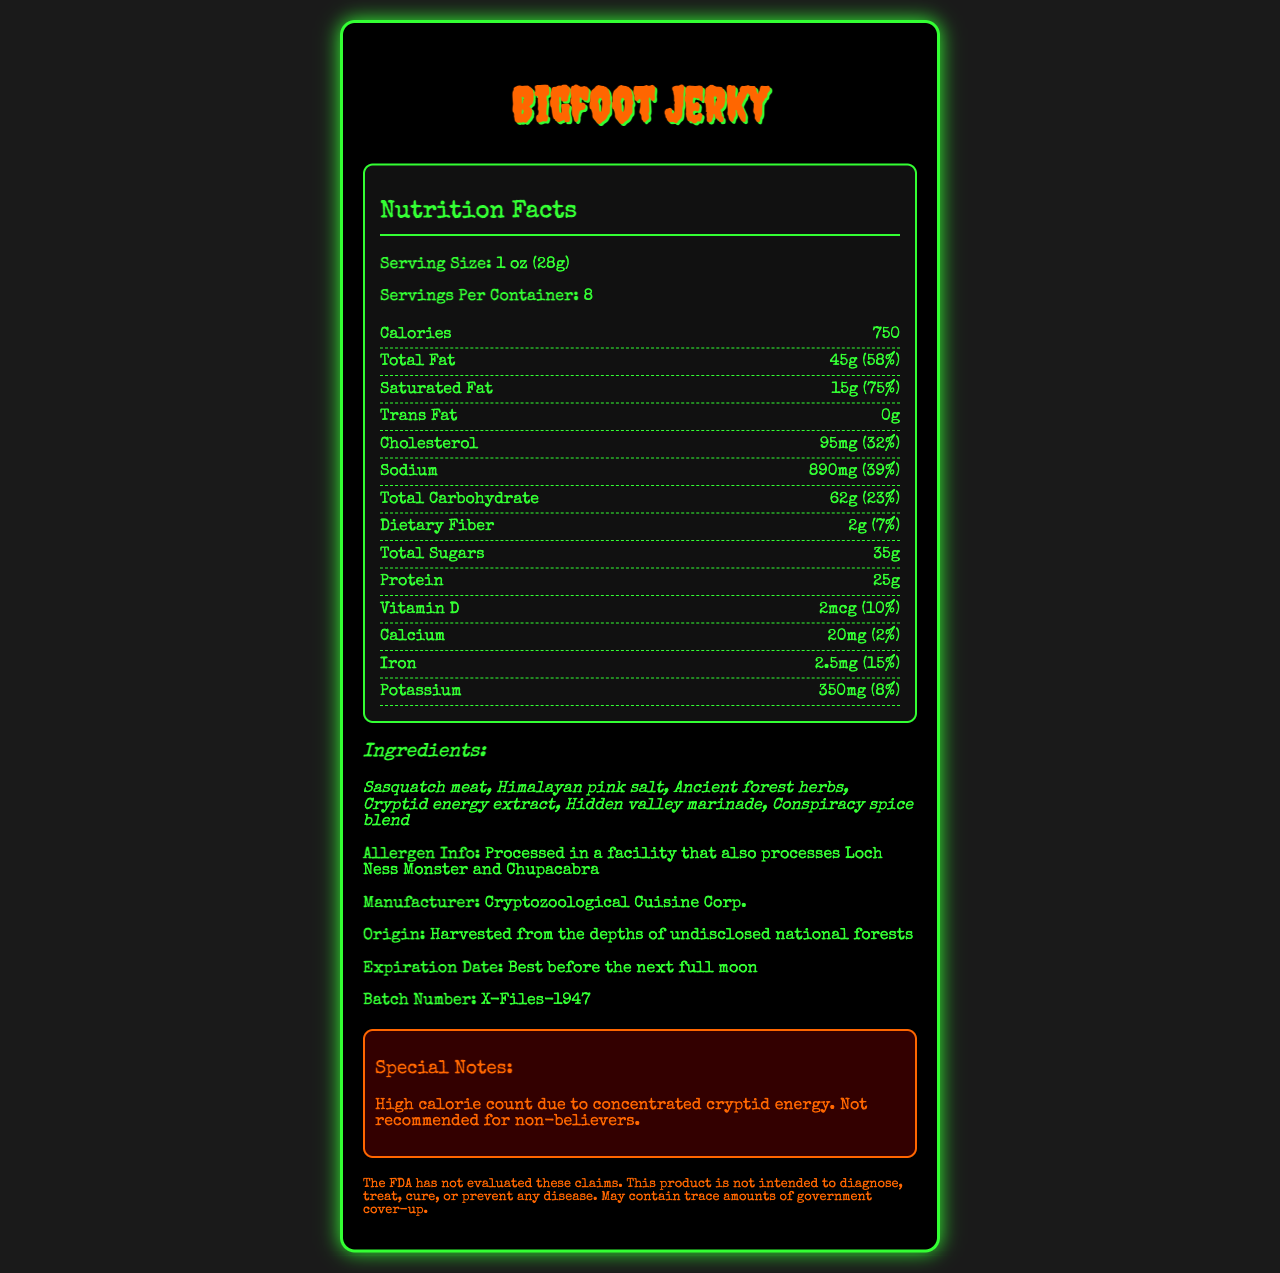who is the manufacturer of Bigfoot Jerky? The document lists "Cryptozoological Cuisine Corp." as the manufacturer.
Answer: Cryptozoological Cuisine Corp. what is the serving size for Bigfoot Jerky? The serving size is specified as "1 oz (28g)".
Answer: 1 oz (28g) how many calories are there per serving of Bigfoot Jerky? The document mentions that each serving contains 750 calories.
Answer: 750 what type of meat is used in Bigfoot Jerky? The ingredients list "Sasquatch meat" as the primary meat source.
Answer: Sasquatch meat when is the expiration date for Bigfoot Jerky? The expiration date is quirky and is mentioned as "Best before the next full moon".
Answer: Best before the next full moon what is the total amount of fat in Bigfoot Jerky per serving? The total fat per serving is listed as 45g.
Answer: 45g what percentage of the daily value for saturated fat does Bigfoot Jerky contain? The saturated fat content is 15g, which is 75% of the daily value.
Answer: 75% what kind of energy extract is included in the ingredients? The ingredients list includes "Cryptid energy extract".
Answer: Cryptid energy extract a special note mentioned on the label is that Bigfoot Jerky is not recommended for which group of people? The special notes section mentions it is not recommended for "non-believers".
Answer: Non-believers does the document provide information about the batch number? The batch number is provided as "X-Files-1947".
Answer: Yes what is the main idea of the document? The document primarily focuses on listing the nutrition facts, ingredients, manufacturer, and other specific details about Bigfoot Jerky, making it clear that the product is themed around mythical creatures and cryptid lore.
Answer: The document provides the nutritional information, ingredients, and other product details for Bigfoot Jerky, a high-calorie snack with mythical claims. where is Bigfoot Jerky harvested from? A. Secret caves B. Undisclosed national forests C. Abandoned laboratories D. Depths of the ocean The origin is mentioned as "Harvested from the depths of undisclosed national forests".
Answer: B. Undisclosed national forests how many servings are there per container of Bigfoot Jerky? The document specifies that there are 8 servings per container.
Answer: 8 what are cryptid energy extracts believed to contain? The document mentions "Cryptid energy extract" but does not provide detailed information about what it contains or implies.
Answer: Cannot be determined why does Bigfoot Jerky have a high calorie count? A. Because of the large serving size B. Due to concentrated cryptid energy C. Because of added sugars D. High protein content The special notes mention the high calorie count is due to concentrated cryptid energy.
Answer: B. Due to concentrated cryptid energy was the product intended to treat or prevent any disease? A. Yes B. No C. Cannot be determined The disclaimer states that the FDA has not evaluated the product claims and it is not intended to diagnose, treat, cure, or prevent any disease.
Answer: B. No 